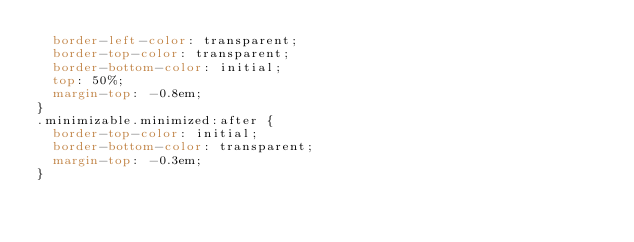Convert code to text. <code><loc_0><loc_0><loc_500><loc_500><_CSS_>  border-left-color: transparent;
  border-top-color: transparent;
  border-bottom-color: initial;
  top: 50%;
  margin-top: -0.8em;
}
.minimizable.minimized:after {
  border-top-color: initial;
  border-bottom-color: transparent;
  margin-top: -0.3em;
}
</code> 